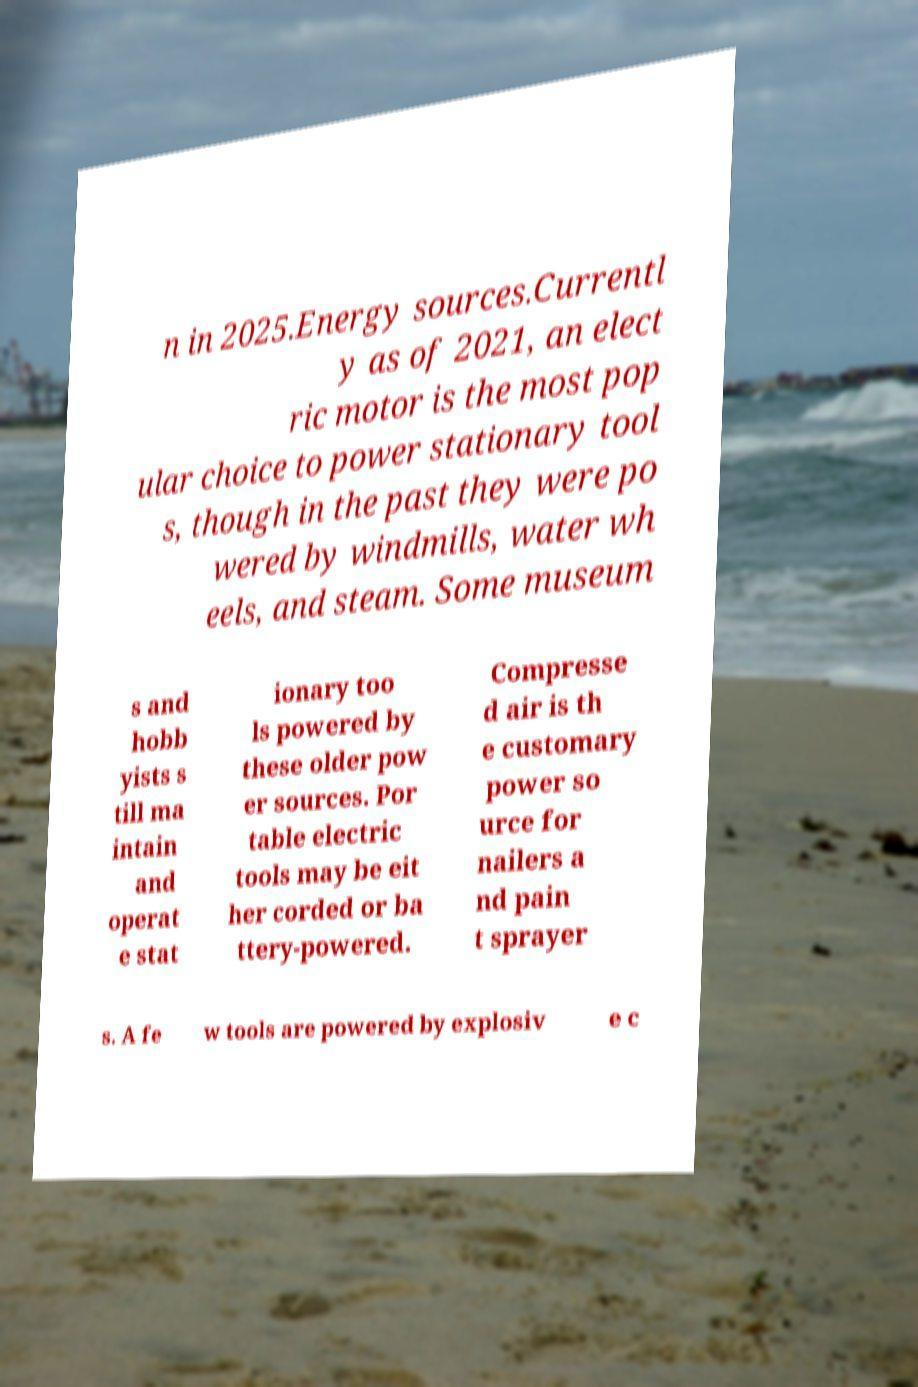Can you accurately transcribe the text from the provided image for me? n in 2025.Energy sources.Currentl y as of 2021, an elect ric motor is the most pop ular choice to power stationary tool s, though in the past they were po wered by windmills, water wh eels, and steam. Some museum s and hobb yists s till ma intain and operat e stat ionary too ls powered by these older pow er sources. Por table electric tools may be eit her corded or ba ttery-powered. Compresse d air is th e customary power so urce for nailers a nd pain t sprayer s. A fe w tools are powered by explosiv e c 